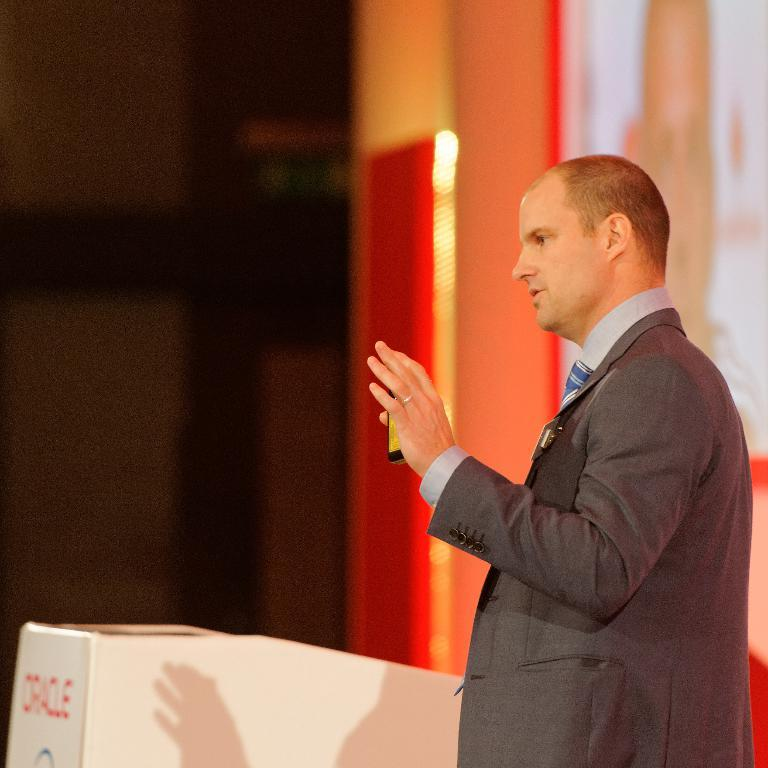What is the person in the image doing? The person is standing in the image. Can you describe the person's attire? The person is wearing a suit and a tie. What is the person holding in his hand? The person is holding an object in his hand. What can be seen in the background of the image? There is a box in the background of the image, but it is blurred. What type of learning is the person engaged in while wearing a coat in the image? The person is not wearing a coat in the image, and there is no indication of any learning activity taking place. Is there a flame visible in the image? No, there is no flame present in the image. 